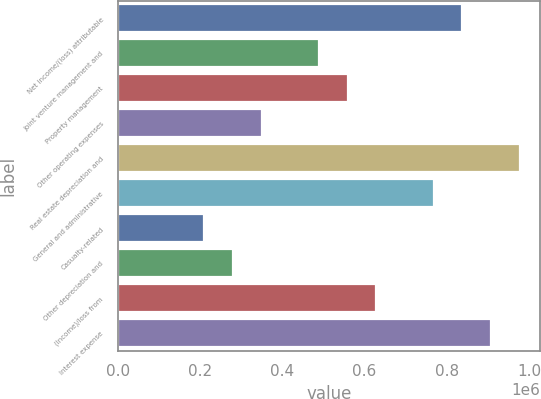<chart> <loc_0><loc_0><loc_500><loc_500><bar_chart><fcel>Net income/(loss) attributable<fcel>Joint venture management and<fcel>Property management<fcel>Other operating expenses<fcel>Real estate depreciation and<fcel>General and administrative<fcel>Casualty-related<fcel>Other depreciation and<fcel>(Income)/loss from<fcel>Interest expense<nl><fcel>838171<fcel>489001<fcel>558835<fcel>349334<fcel>977839<fcel>768337<fcel>209666<fcel>279500<fcel>628669<fcel>908005<nl></chart> 